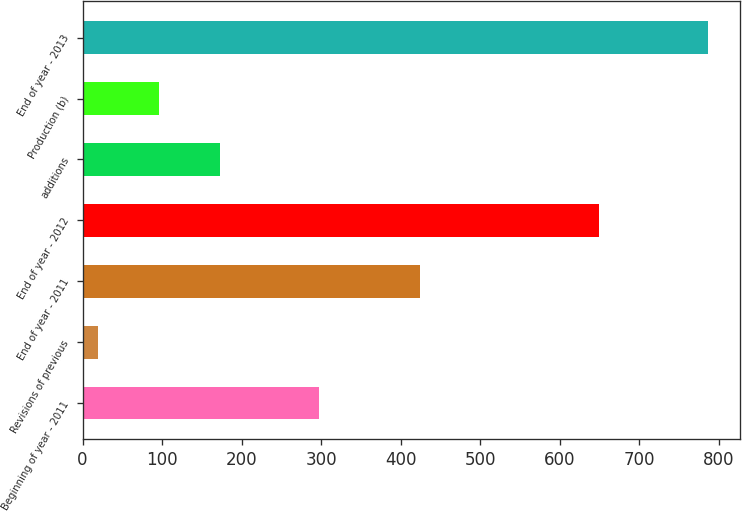Convert chart to OTSL. <chart><loc_0><loc_0><loc_500><loc_500><bar_chart><fcel>Beginning of year - 2011<fcel>Revisions of previous<fcel>End of year - 2011<fcel>End of year - 2012<fcel>additions<fcel>Production (b)<fcel>End of year - 2013<nl><fcel>297<fcel>19<fcel>424<fcel>649<fcel>172.6<fcel>95.8<fcel>787<nl></chart> 